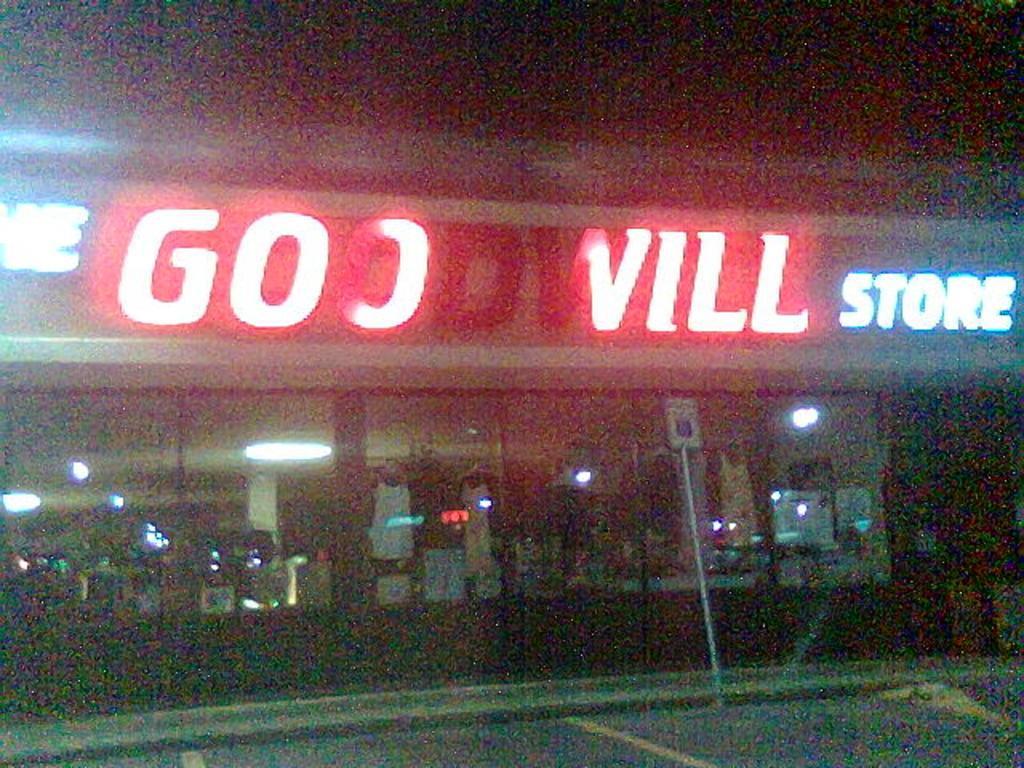How would you summarize this image in a sentence or two? In this picture we can see a store, there is a board in the front, we can see some text and glasses in the middle, from these glasses we can see lights. 